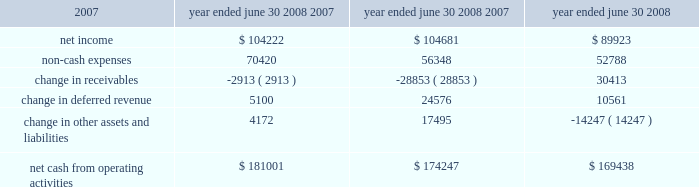L iquidity and capital resources we have historically generated positive cash flow from operations and have generally used funds generated from operations and short-term borrowings on our revolving credit facility to meet capital requirements .
We expect this trend to continue in the future .
The company's cash and cash equivalents decreased to $ 65565 at june 30 , 2008 from $ 88617 at june 30 , 2007 .
The table summarizes net cash from operating activities in the statement of cash flows : year ended june 30 cash provided by operations increased $ 6754 to $ 181001 for the fiscal year ended june 30 , 2008 as compared to $ 174247 for the fiscal year ended june 30 , 2007 .
This increase is primarily attributable to an increase in expenses that do not have a corresponding cash outflow , such as depreciation and amortization , as a percentage of total net income .
Cash used in investing activities for the fiscal year ended june 2008 was $ 102148 and includes payments for acquisitions of $ 48109 , plus $ 1215 in contingent consideration paid on prior years 2019 acquisitions .
During fiscal 2007 , payments for acquisitions totaled $ 34006 , plus $ 5301 paid on earn-outs and other acquisition adjustments .
Capital expenditures for fiscal 2008 were $ 31105 compared to $ 34202 for fiscal 2007 .
Cash used for software development in fiscal 2008 was $ 23736 compared to $ 20743 during the prior year .
Net cash used in financing activities for the current fiscal year was $ 101905 and includes the repurchase of 4200 shares of our common stock for $ 100996 , the payment of dividends of $ 24683 and $ 429 net repayment on our revolving credit facilities .
Cash used in financing activities was partially offset by proceeds of $ 20394 from the exercise of stock options and the sale of common stock and $ 3809 excess tax benefits from stock option exercises .
During fiscal 2007 , net cash used in financing activities included the repurchase of our common stock for $ 98413 and the payment of dividends of $ 21685 .
As in the current year , cash used in fiscal 2007 was partially offset by proceeds from the exercise of stock options and the sale of common stock of $ 29212 , $ 4640 excess tax benefits from stock option exercises and $ 19388 net borrowings on revolving credit facilities .
At june 30 , 2008 , the company had negative working capital of $ 11418 ; however , the largest component of current liabilities was deferred revenue of $ 212375 .
The cash outlay necessary to provide the services related to these deferred revenues is significantly less than this recorded balance .
Therefore , we do not anticipate any liquidity problems to result from this condition .
U.s .
Financial markets and many of the largest u.s .
Financial institutions have recently been shaken by negative developments in the home mortgage industry and the mortgage markets , and particularly the markets for subprime mortgage-backed securities .
While we believe it is too early to predict what effect , if any , these developments may have , we have not experienced any significant issues with our current collec- tion efforts , and we believe that any future impact to our liquidity would be minimized by our access to available lines of credit .
2008 2007 2006 .

What was change in millions of cash used for software development in fiscal 2008 compared to the prior year? 
Computations: (23736 - 20743)
Answer: 2993.0. 